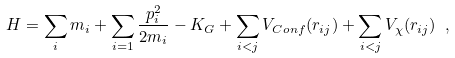Convert formula to latex. <formula><loc_0><loc_0><loc_500><loc_500>H = \sum _ { i } m _ { i } + \sum _ { i = 1 } { \frac { p _ { i } ^ { 2 } } { 2 m _ { i } } } - K _ { G } + \sum _ { i < j } V _ { C o n f } ( r _ { i j } ) + \sum _ { i < j } V _ { \chi } ( r _ { i j } ) \ ,</formula> 